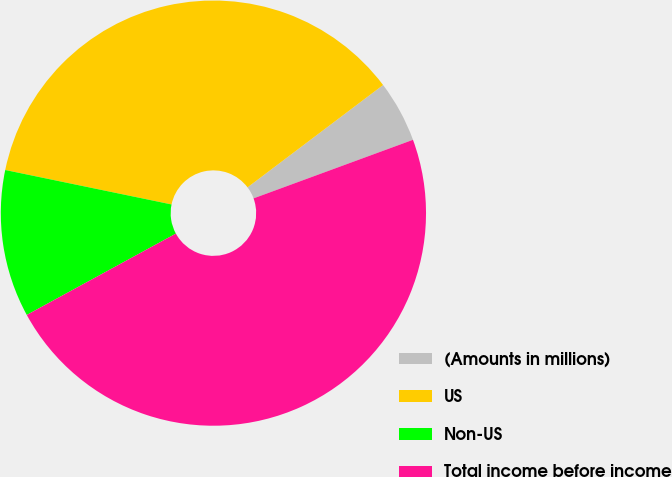<chart> <loc_0><loc_0><loc_500><loc_500><pie_chart><fcel>(Amounts in millions)<fcel>US<fcel>Non-US<fcel>Total income before income<nl><fcel>4.69%<fcel>36.46%<fcel>11.2%<fcel>47.66%<nl></chart> 